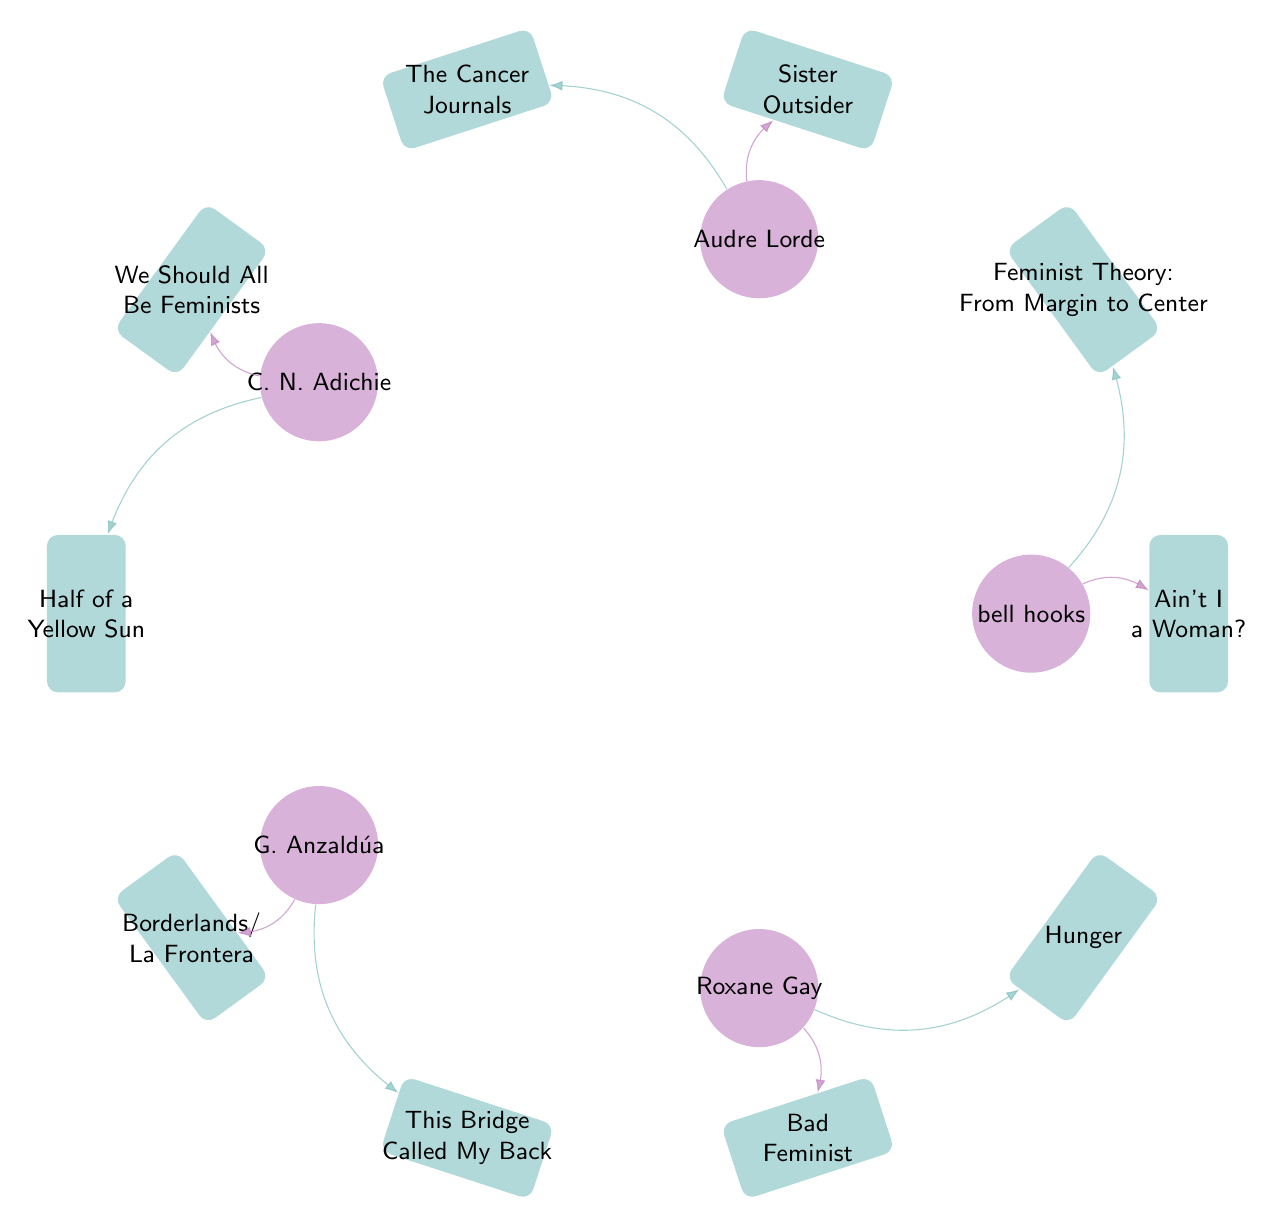What is the total number of authors represented in the diagram? The diagram lists five authors: bell hooks, Audre Lorde, Chimamanda Ngozi Adichie, Gloria Anzaldúa, and Roxane Gay. Therefore, counting these gives a total of five distinct authors.
Answer: 5 Which book is connected to Audre Lorde? Audre Lorde is connected to two books: 'Sister Outsider' and 'The Cancer Journals', but just one is needed. Therefore, choosing the first book listed, 'Sister Outsider' is the correct answer.
Answer: Sister Outsider How many books are associated with Roxane Gay? The diagram shows that Roxane Gay is linked to two specific books: 'Bad Feminist' and 'Hunger'. Hence, the count of books associated with Roxane Gay is two.
Answer: 2 What is the relationship between bell hooks and 'Ain't I a Woman?' In the diagram, there is a direct connection between the author bell hooks and the book 'Ain't I a Woman?'. The line directly bends from bell hooks to this specific book, indicating their relationship.
Answer: Ain't I a Woman? Which author has written 'Half of a Yellow Sun'? The book 'Half of a Yellow Sun' is associated with Chimamanda Ngozi Adichie in the diagram, as it shows her directly linked to this title.
Answer: Chimamanda Ngozi Adichie Which book appears to be the most recent addition to the works of the authors shown? The book titles themselves do not provide direct chronological information, but 'Hunger' by Roxane Gay was published in 2017, which is later than the others listed. Hence, this would be considered the most recent addition to the author's works depicted.
Answer: Hunger What type of connections are shown in the diagram? The connections in the diagram are directed edges that represent relationships between authors and their respective works. They indicate which works belong to which authors, using arrows that bend around the diagram.
Answer: Directed edges How many works are attributed to Chimamanda Ngozi Adichie? According to the diagram, Chimamanda Ngozi Adichie is linked to two works: 'We Should All Be Feminists' and 'Half of a Yellow Sun'. By counting these titles, we get the total number of works attributed to her.
Answer: 2 